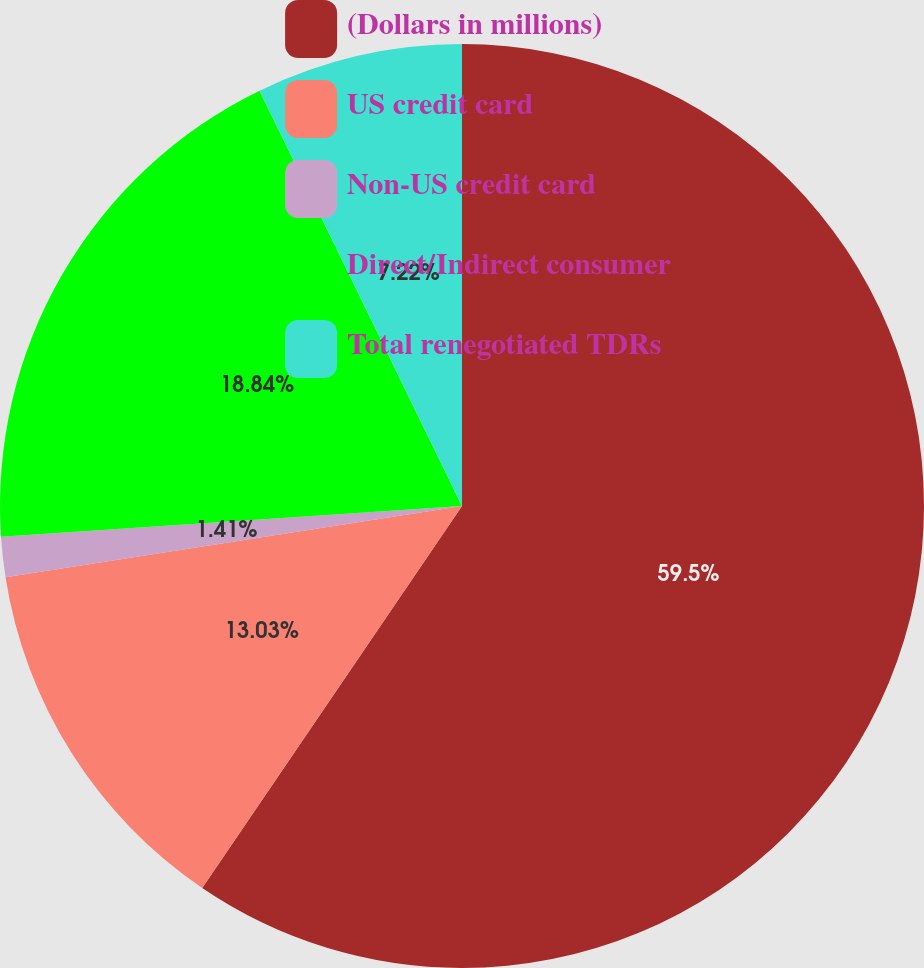<chart> <loc_0><loc_0><loc_500><loc_500><pie_chart><fcel>(Dollars in millions)<fcel>US credit card<fcel>Non-US credit card<fcel>Direct/Indirect consumer<fcel>Total renegotiated TDRs<nl><fcel>59.51%<fcel>13.03%<fcel>1.41%<fcel>18.84%<fcel>7.22%<nl></chart> 